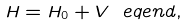<formula> <loc_0><loc_0><loc_500><loc_500>H = H _ { 0 } + V \ e q e n d { , }</formula> 